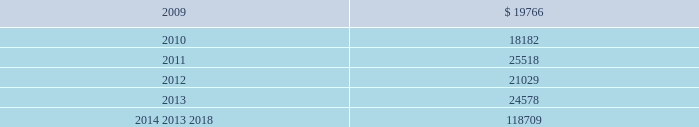Mastercard incorporated notes to consolidated financial statements 2014 ( continued ) ( in thousands , except percent and per share data ) the table summarizes expected benefit payments through 2018 including those payments expected to be paid from the company 2019s general assets .
Since the majority of the benefit payments are made in the form of lump-sum distributions , actual benefit payments may differ from expected benefits payments. .
Substantially all of the company 2019s u.s .
Employees are eligible to participate in a defined contribution savings plan ( the 201csavings plan 201d ) sponsored by the company .
The savings plan allows employees to contribute a portion of their base compensation on a pre-tax and after-tax basis in accordance with specified guidelines .
The company matches a percentage of employees 2019 contributions up to certain limits .
In 2007 and prior years , the company could also contribute to the savings plan a discretionary profit sharing component linked to company performance during the prior year .
Beginning in 2008 , the discretionary profit sharing amount related to 2007 company performance was paid directly to employees as a short-term cash incentive bonus rather than as a contribution to the savings plan .
In addition , the company has several defined contribution plans outside of the united states .
The company 2019s contribution expense related to all of its defined contribution plans was $ 35341 , $ 26996 and $ 43594 for 2008 , 2007 and 2006 , respectively .
The company had a value appreciation program ( 201cvap 201d ) , which was an incentive compensation plan established in 1995 .
Annual awards were granted to vap participants from 1995 through 1998 , which entitled participants to the net appreciation on a portfolio of securities of members of mastercard international .
In 1999 , the vap was replaced by an executive incentive plan ( 201ceip 201d ) and the senior executive incentive plan ( 201cseip 201d ) ( together the 201ceip plans 201d ) ( see note 16 ( share based payments and other benefits ) ) .
Contributions to the vap have been discontinued , all plan assets have been disbursed and no vap liability remained as of december 31 , 2008 .
The company 2019s liability related to the vap at december 31 , 2007 was $ 986 .
The expense ( benefit ) was $ ( 6 ) , $ ( 267 ) and $ 3406 for the years ended december 31 , 2008 , 2007 and 2006 , respectively .
Note 12 .
Postemployment and postretirement benefits the company maintains a postretirement plan ( the 201cpostretirement plan 201d ) providing health coverage and life insurance benefits for substantially all of its u.s .
Employees and retirees hired before july 1 , 2007 .
The company amended the life insurance benefits under the postretirement plan effective january 1 , 2007 .
The impact , net of taxes , of this amendment was an increase of $ 1715 to accumulated other comprehensive income in 2007. .
Considering the years 2007-2008 , what was the increase observed in the expense related to all of the defined contribution plans? 
Rationale: it is the value of the expense related to all of the defined contribution plans in 2008 divided by the 2007's , then subtracted 1 and turned into a percentage .
Computations: ((35341 / 26996) - 1)
Answer: 0.30912. 